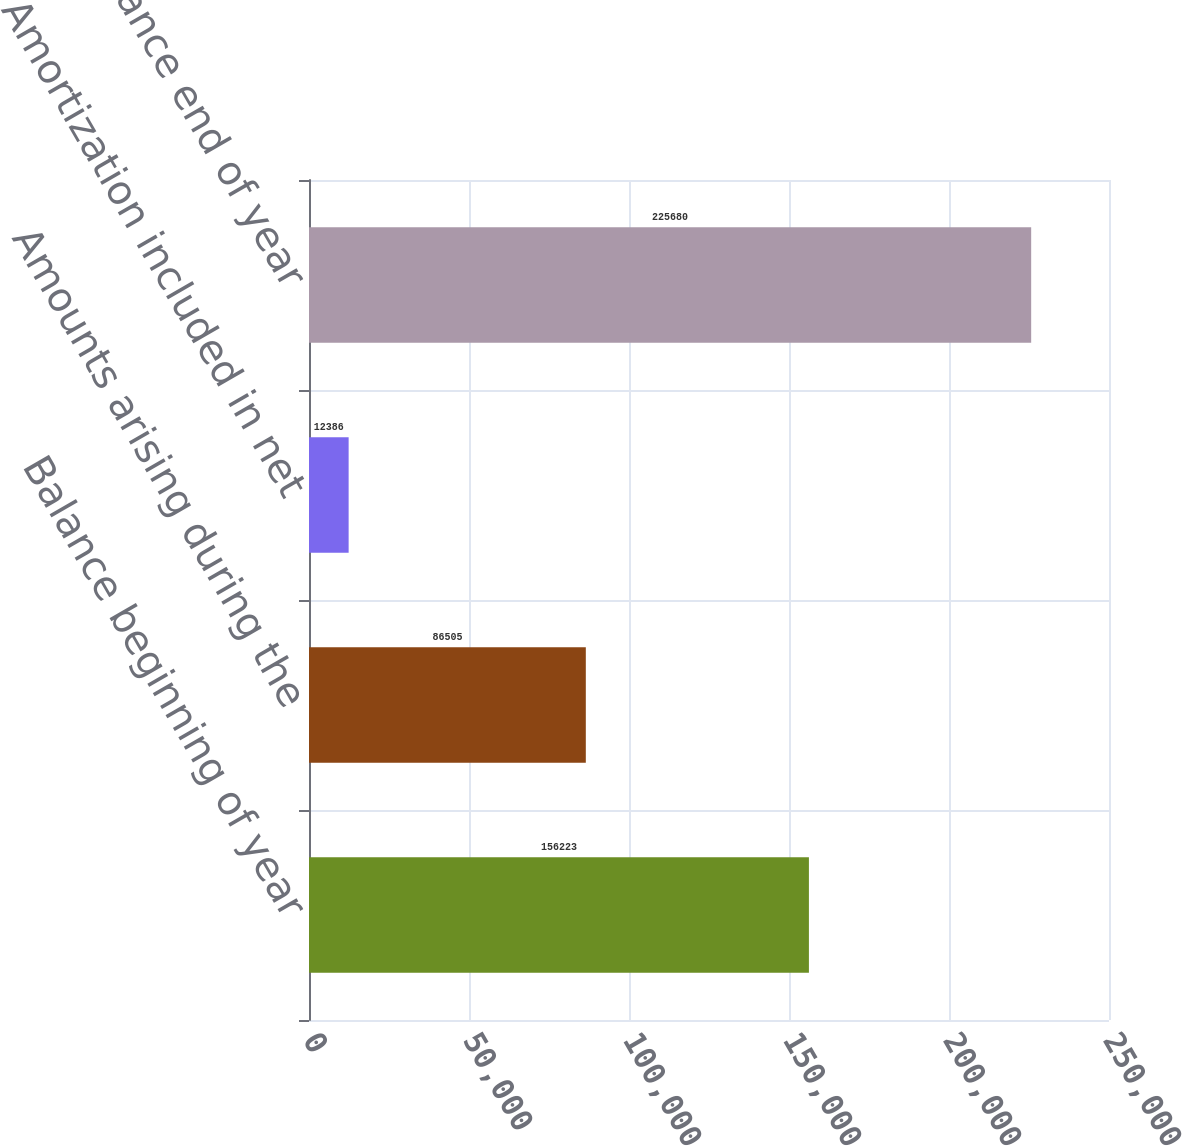<chart> <loc_0><loc_0><loc_500><loc_500><bar_chart><fcel>Balance beginning of year<fcel>Amounts arising during the<fcel>Amortization included in net<fcel>Balance end of year<nl><fcel>156223<fcel>86505<fcel>12386<fcel>225680<nl></chart> 